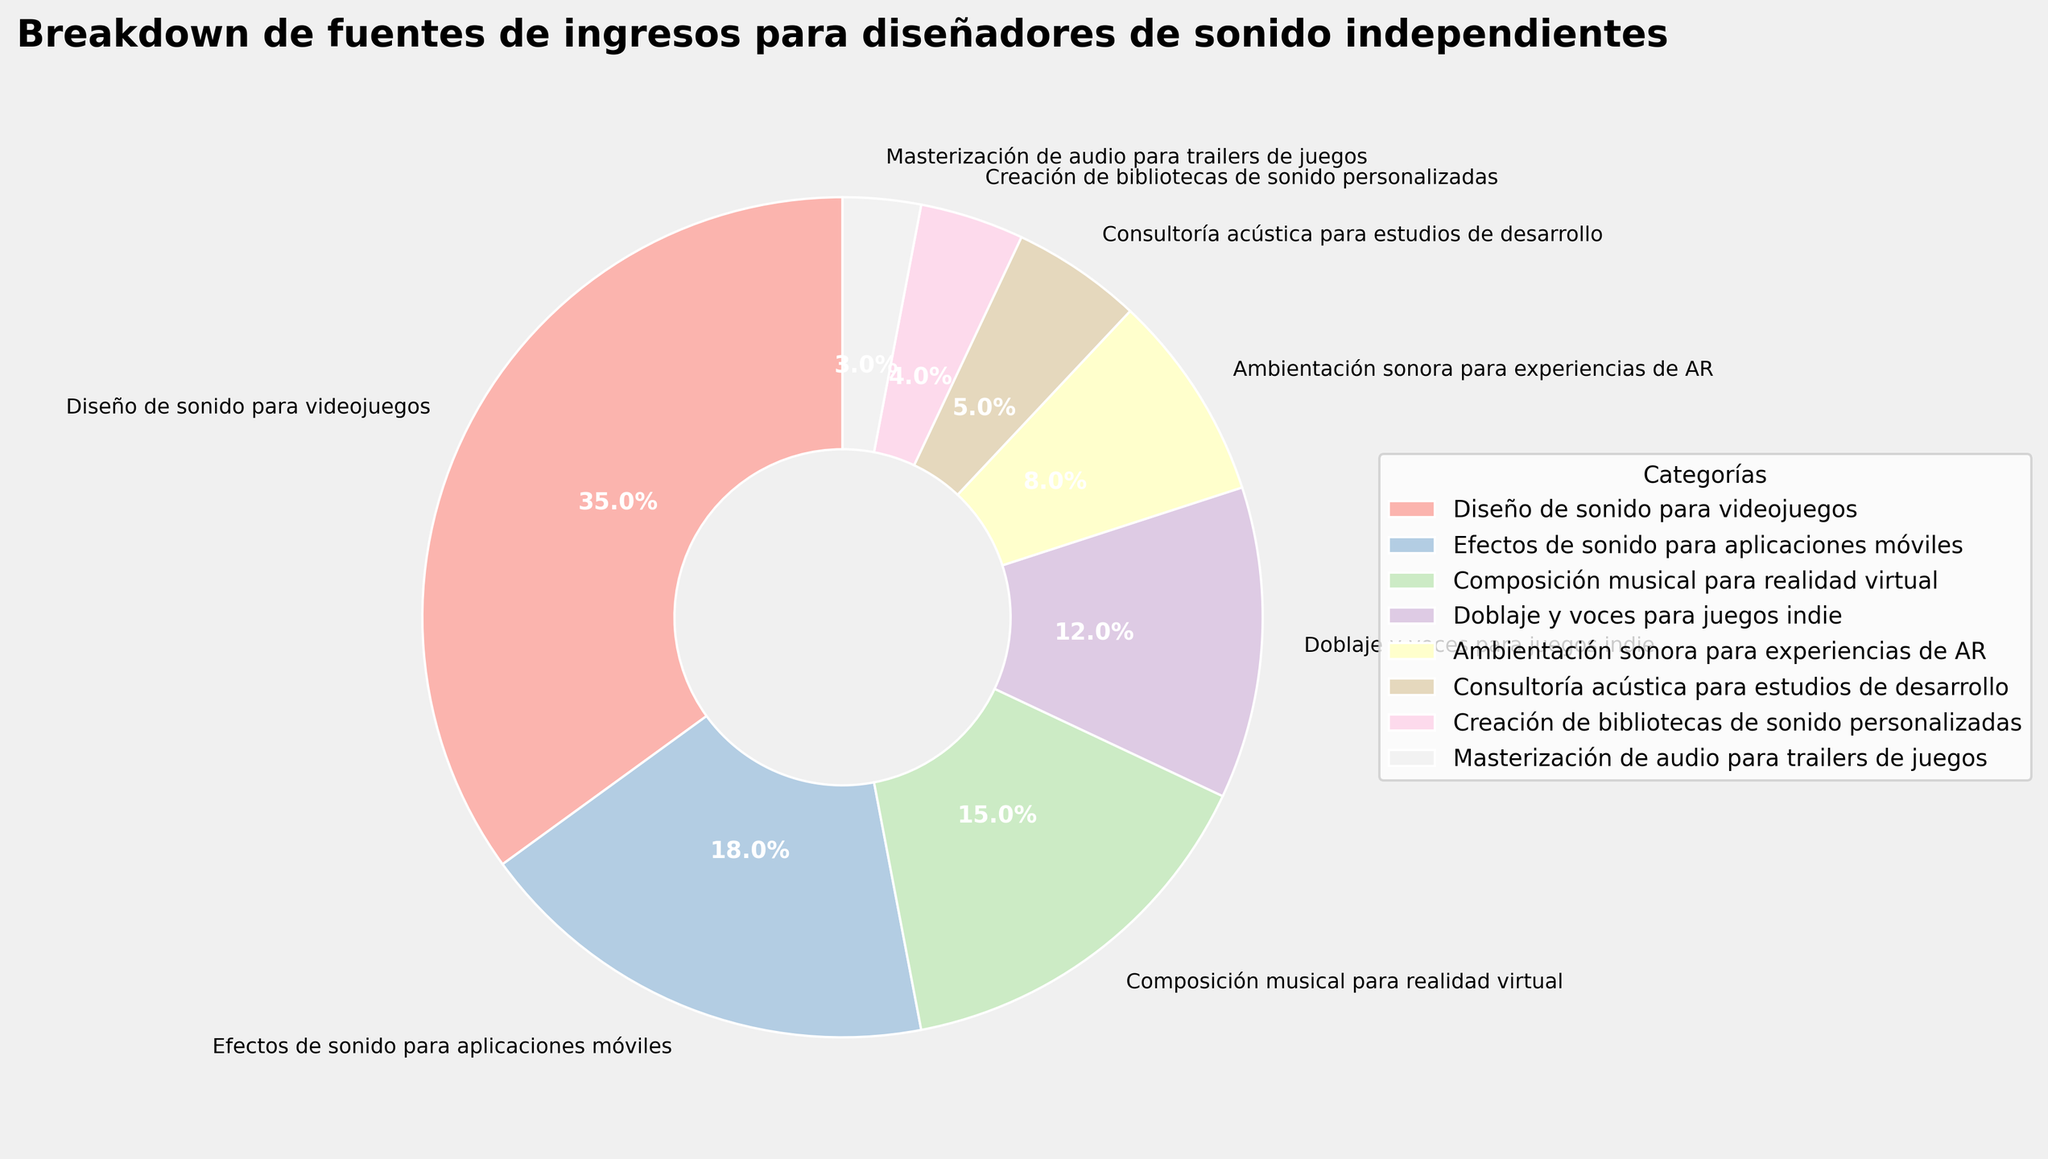¿Cuál categoría representa el mayor porcentaje? Al observar el gráfico, se puede ver que la categoría "Diseño de sonido para videojuegos" tiene el área más grande, lo que indica el mayor porcentaje.
Answer: Diseño de sonido para videojuegos ¿Cuál es el porcentaje combinado de "Efectos de sonido para aplicaciones móviles" y "Doblaje y voces para juegos indie"? Para encontrar la suma de estos dos porcentajes, sumamos 18% (Efectos de sonido para aplicaciones móviles) + 12% (Doblaje y voces para juegos indie) = 30%.
Answer: 30% ¿Cuál es la diferencia porcentual entre "Composición musical para realidad virtual" y "Ambientación sonora para experiencias de AR"? Restamos el porcentaje de "Ambientación sonora para experiencias de AR" (8%) del porcentaje de "Composición musical para realidad virtual" (15%): 15% - 8% = 7%.
Answer: 7% ¿Cuántas categorías representan menos del 10% cada una? Al observar el gráfico, las categorías que representan menos del 10% son: "Ambientación sonora para experiencias de AR" (8%), "Consultoría acústica para estudios de desarrollo" (5%), "Creación de bibliotecas de sonido personalizadas" (4%) y "Masterización de audio para trailers de juegos" (3%). En total, hay 4 categorías.
Answer: 4 ¿Qué categorías combinadas representan un porcentaje mayor que "Diseño de sonido para videojuegos"? Sumamos las categorías en orden decreciente hasta superar 35%. Al sumar los siguientes porcentajes: 18% + 15% + 12% obtenemos 45%, que es mayor que 35%. Esto incluye "Efectos de sonido para aplicaciones móviles", "Composición musical para realidad virtual" y "Doblaje y voces para juegos indie".
Answer: Efectos de sonido para aplicaciones móviles, Composición musical para realidad virtual, Doblaje y voces para juegos indie ¿Cuál es el color asociado a la categoría "Consultoría acústica para estudios de desarrollo" en el gráfico? Al identificar la leyenda en el gráfico, se puede ver que "Consultoría acústica para estudios de desarrollo" está representado por un color específico. En este caso sería necesario observar el gráfico para identificar que probablemente es un tono pastel.
Answer: (Color tono pastel específico, aquí ejemplo: rosa) ¿Cuál categoría tiene el porcentaje más cercano a 5%? Observamos el gráfico y notamos que "Consultoría acústica para estudios de desarrollo" tiene un porcentaje de 5%, que es igual al porcentaje dado en la pregunta.
Answer: Consultoría acústica para estudios de desarrollo 